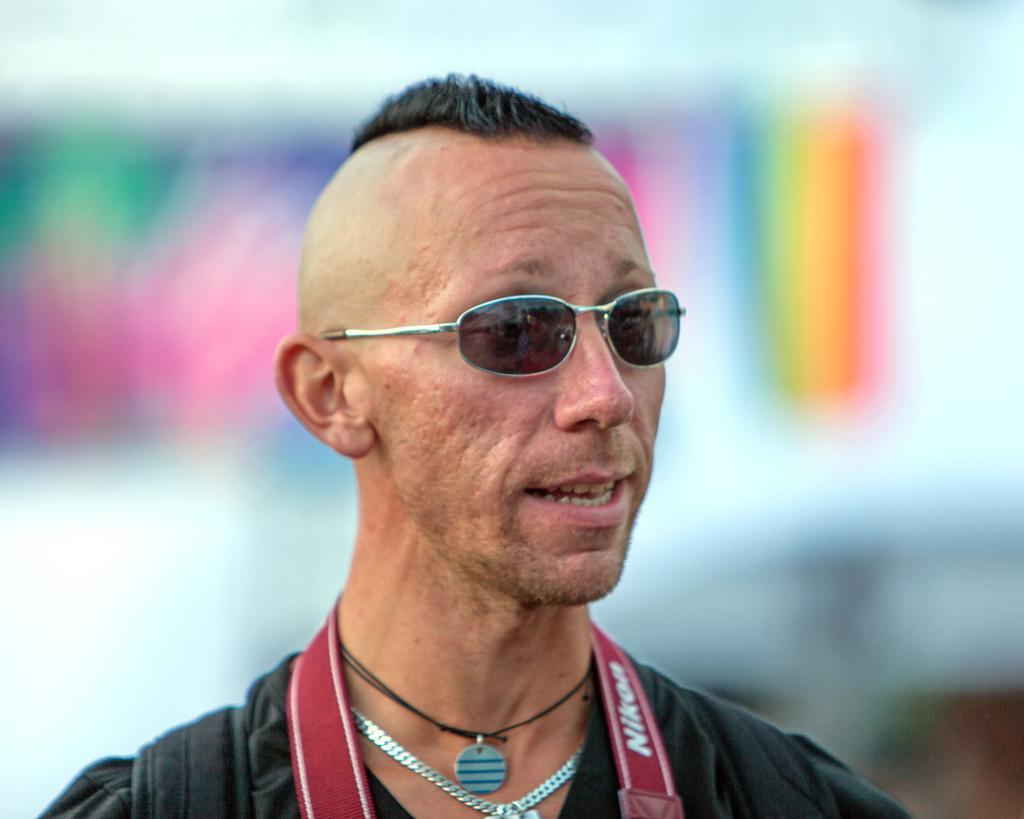Please provide a concise description of this image. In the image there is a man in black dress with chains on his neck, he is wearing glasses and the background is blurry. 